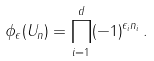<formula> <loc_0><loc_0><loc_500><loc_500>\phi _ { \epsilon } ( U _ { n } ) = \prod _ { i = 1 } ^ { d } ( - 1 ) ^ { \epsilon _ { i } n _ { i } } \, .</formula> 